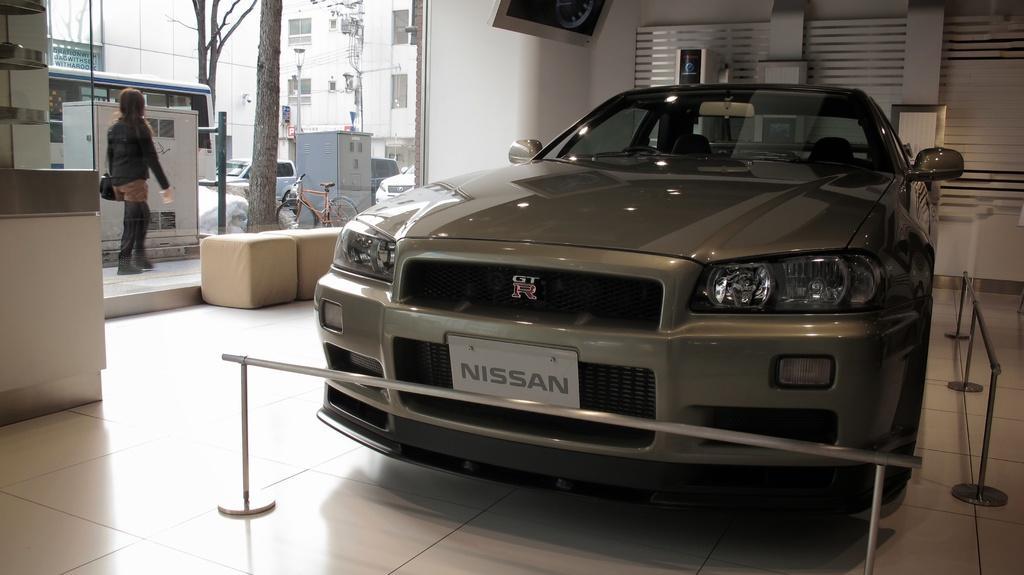Could you give a brief overview of what you see in this image? In this image in the middle there is a car. On the left there is a woman, she wears a jacket, trouser, shoes and bag, she is walking. On the left there are cars, chairs, trees, buildings, bus, wall, glass and screen. At the bottom there is a floor. 